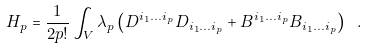Convert formula to latex. <formula><loc_0><loc_0><loc_500><loc_500>H _ { p } = \frac { 1 } { 2 p ! } \int _ { V } \lambda _ { p } \left ( D ^ { i _ { 1 } \dots i _ { p } } D _ { i _ { 1 } \dots i _ { p } } + B ^ { i _ { 1 } \dots i _ { p } } B _ { i _ { 1 } \dots i _ { p } } \right ) \ .</formula> 